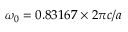<formula> <loc_0><loc_0><loc_500><loc_500>\omega _ { 0 } = 0 . 8 3 1 6 7 \times 2 \pi c / a</formula> 